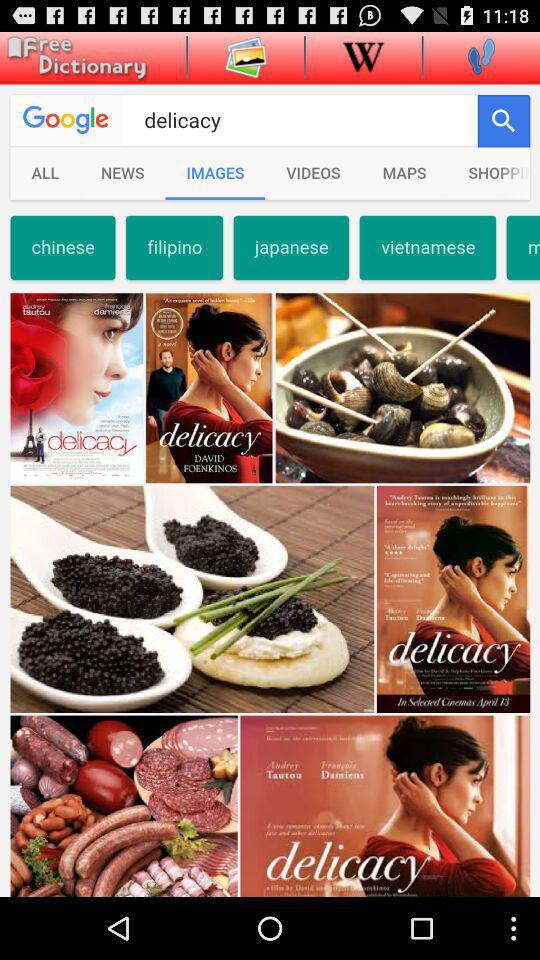Which tab is currently selected? The currently selected tab is "IMAGES". 